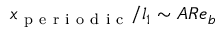<formula> <loc_0><loc_0><loc_500><loc_500>x _ { p e r i o d i c } / l _ { 1 } \sim A R e _ { b }</formula> 